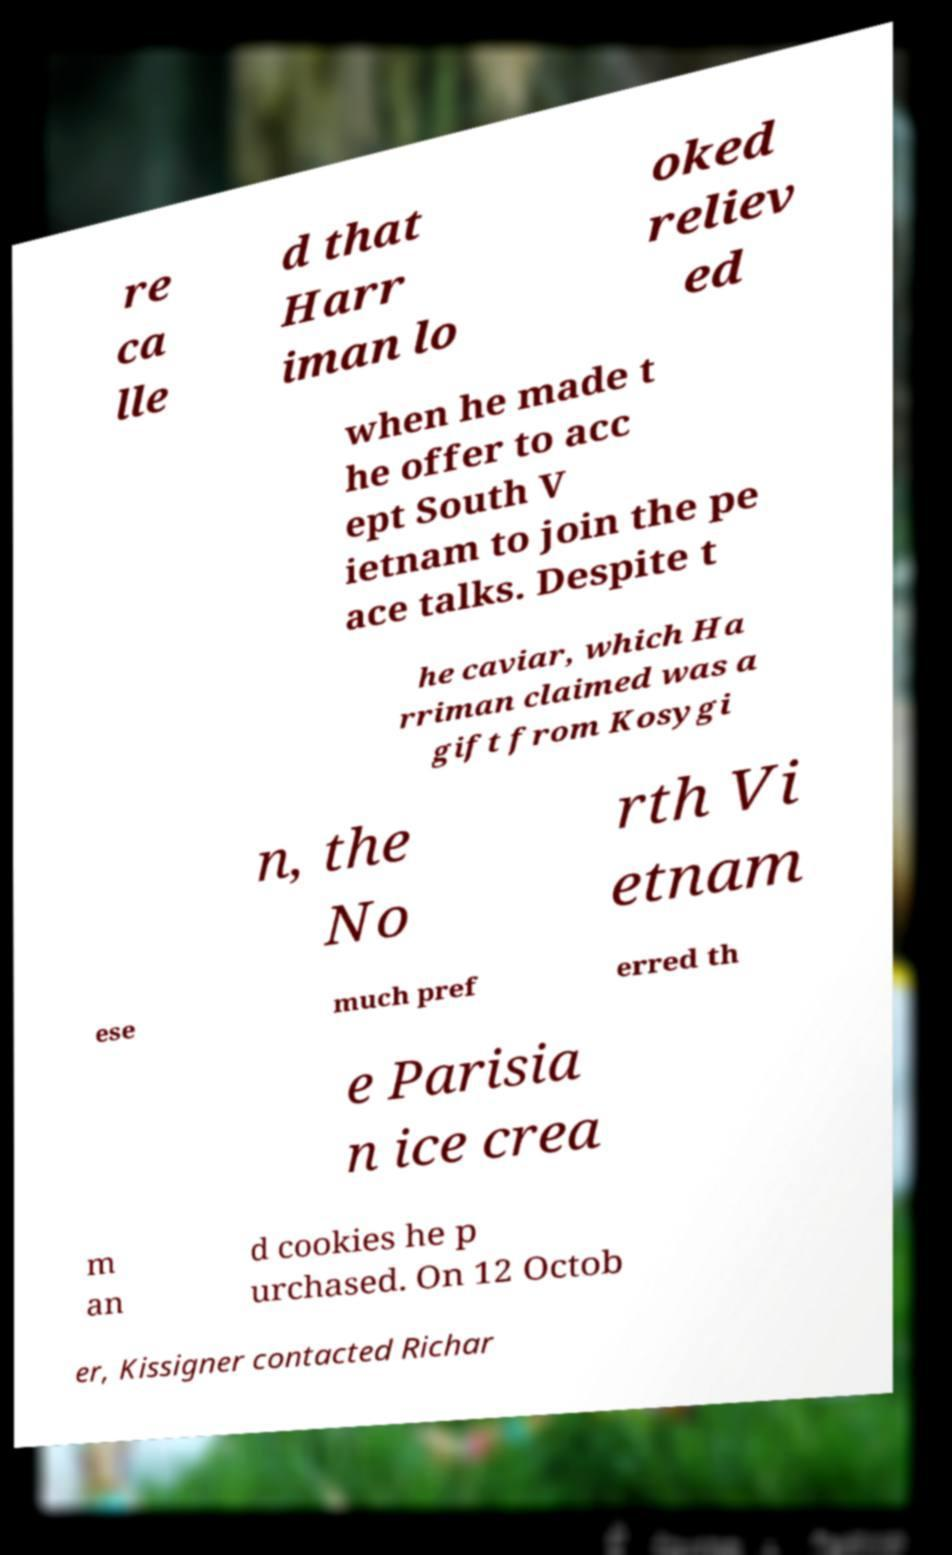There's text embedded in this image that I need extracted. Can you transcribe it verbatim? re ca lle d that Harr iman lo oked reliev ed when he made t he offer to acc ept South V ietnam to join the pe ace talks. Despite t he caviar, which Ha rriman claimed was a gift from Kosygi n, the No rth Vi etnam ese much pref erred th e Parisia n ice crea m an d cookies he p urchased. On 12 Octob er, Kissigner contacted Richar 